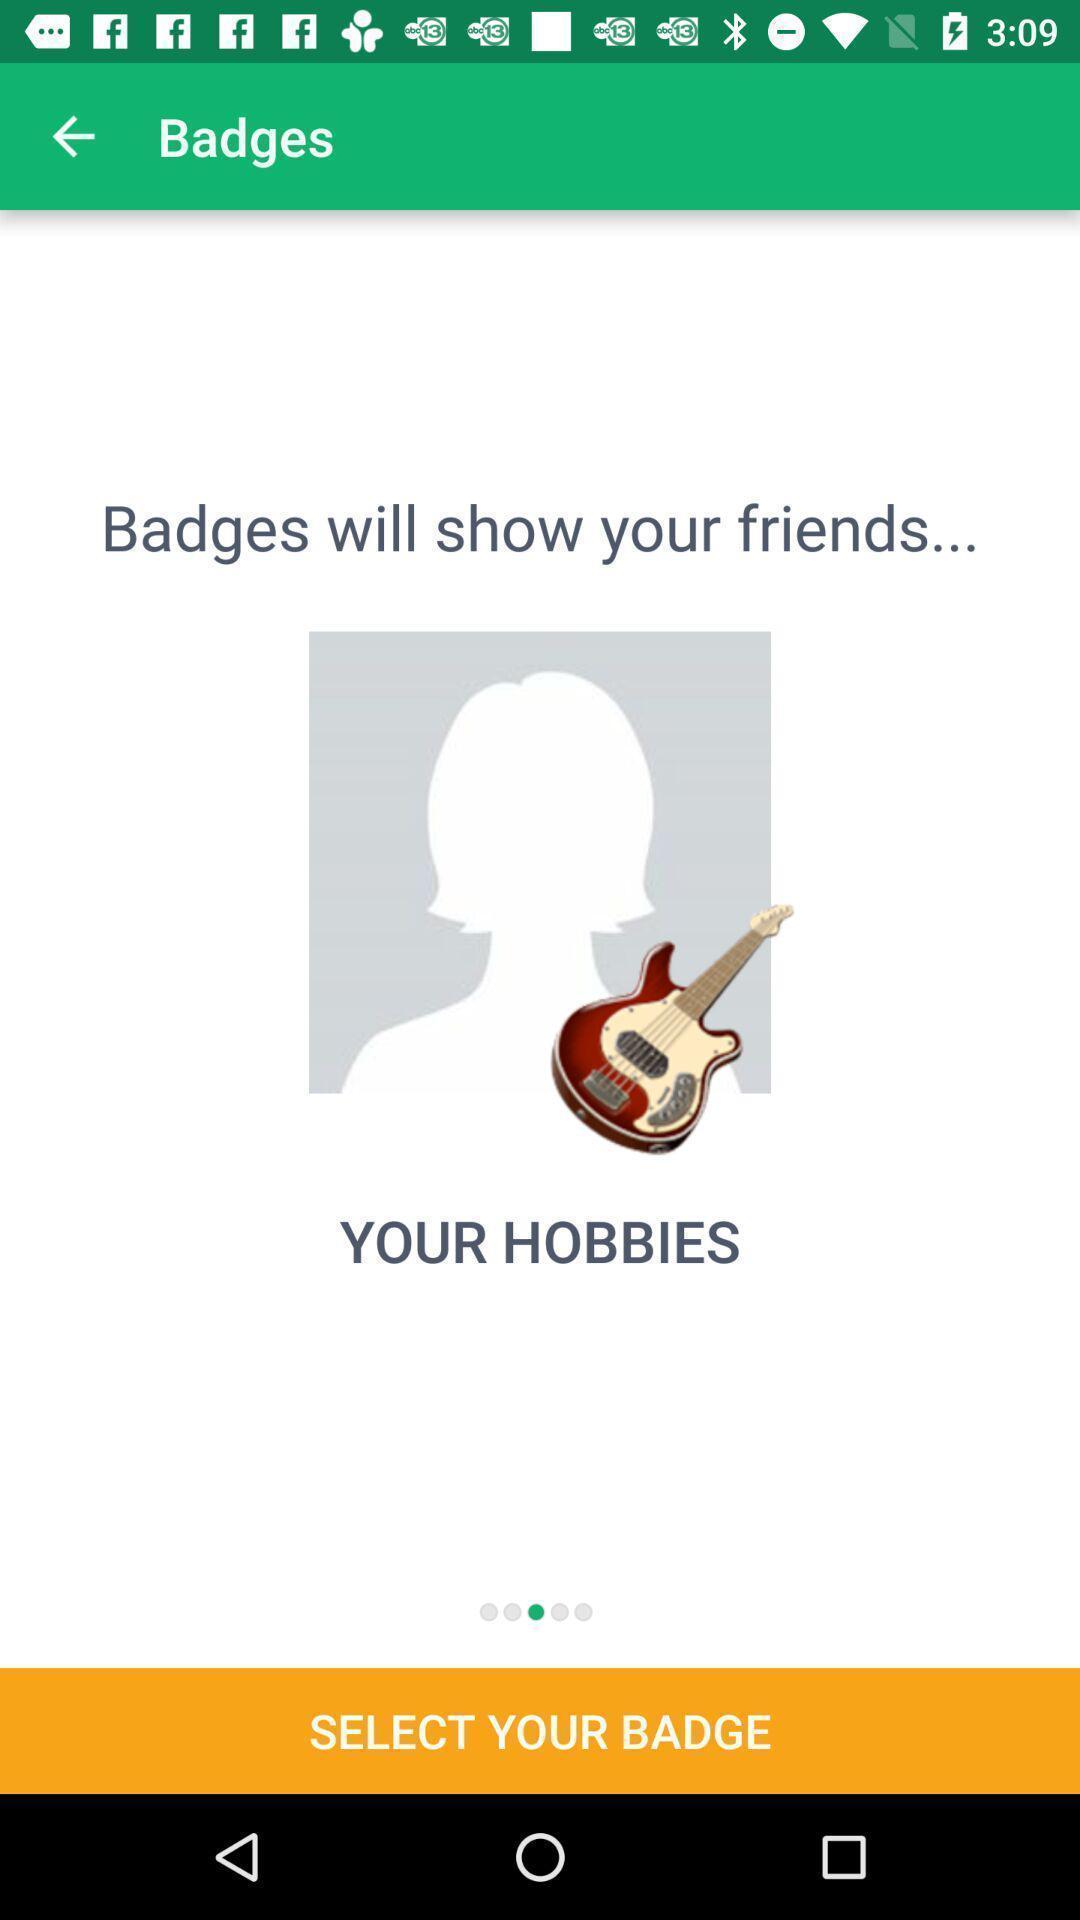Give me a summary of this screen capture. Select badge to find friends of a friends location app. 